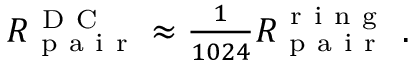<formula> <loc_0><loc_0><loc_500><loc_500>\begin{array} { r } { R _ { p a i r } ^ { D C } \approx \frac { 1 } { 1 0 2 4 } R _ { p a i r } ^ { r i n g } \ . } \end{array}</formula> 